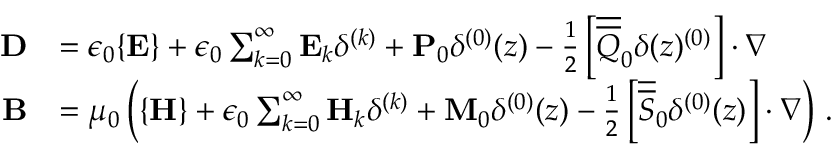<formula> <loc_0><loc_0><loc_500><loc_500>\begin{array} { r l } { D } & { = \epsilon _ { 0 } \{ E \} + \epsilon _ { 0 } \sum _ { k = 0 } ^ { \infty } E _ { k } \delta ^ { ( k ) } + P _ { 0 } \delta ^ { ( 0 ) } ( z ) - \frac { 1 } { 2 } \left [ \overline { { \overline { Q } } } _ { 0 } \delta ( z ) ^ { ( 0 ) } \right ] \cdot \nabla } \\ { B } & { = \mu _ { 0 } \left ( \{ H \} + \epsilon _ { 0 } \sum _ { k = 0 } ^ { \infty } H _ { k } \delta ^ { ( k ) } + M _ { 0 } \delta ^ { ( 0 ) } ( z ) - \frac { 1 } { 2 } \left [ \overline { { \overline { S } } } _ { 0 } \delta ^ { ( 0 ) } ( z ) \right ] \cdot \nabla \right ) \, . } \end{array}</formula> 